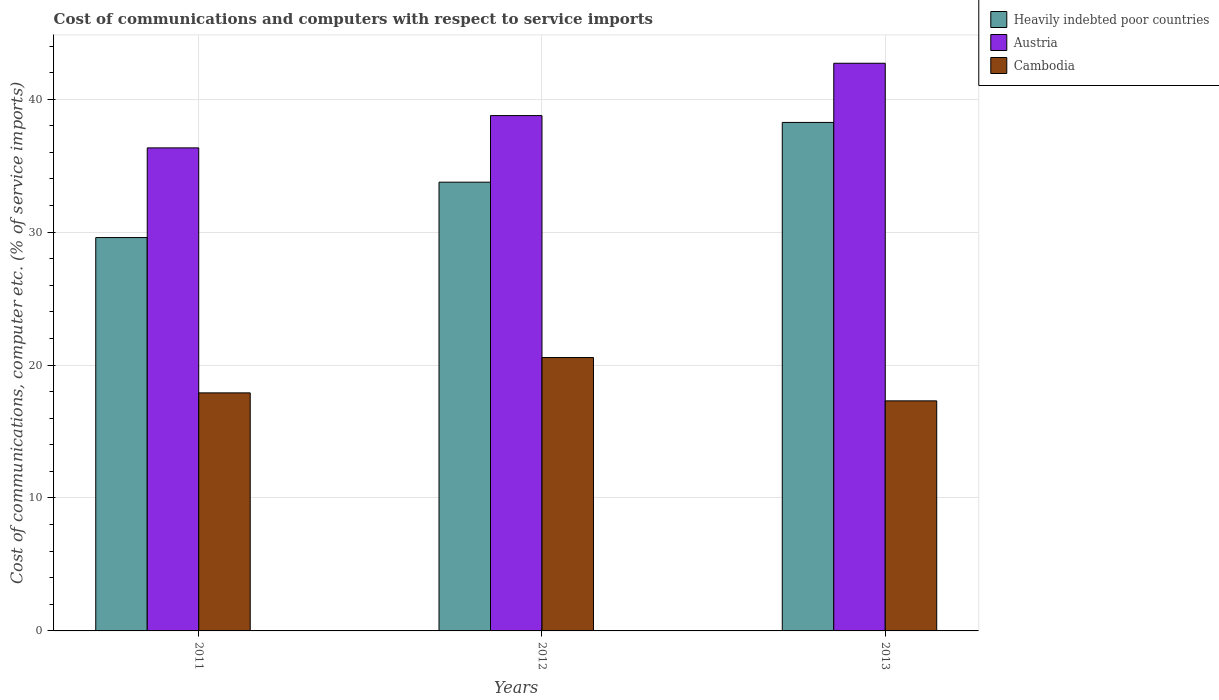Are the number of bars per tick equal to the number of legend labels?
Keep it short and to the point. Yes. Are the number of bars on each tick of the X-axis equal?
Keep it short and to the point. Yes. How many bars are there on the 1st tick from the left?
Your response must be concise. 3. In how many cases, is the number of bars for a given year not equal to the number of legend labels?
Keep it short and to the point. 0. What is the cost of communications and computers in Cambodia in 2012?
Make the answer very short. 20.57. Across all years, what is the maximum cost of communications and computers in Austria?
Make the answer very short. 42.7. Across all years, what is the minimum cost of communications and computers in Austria?
Provide a short and direct response. 36.34. In which year was the cost of communications and computers in Cambodia maximum?
Give a very brief answer. 2012. What is the total cost of communications and computers in Austria in the graph?
Your answer should be compact. 117.81. What is the difference between the cost of communications and computers in Austria in 2012 and that in 2013?
Your answer should be compact. -3.94. What is the difference between the cost of communications and computers in Austria in 2012 and the cost of communications and computers in Cambodia in 2013?
Provide a short and direct response. 21.46. What is the average cost of communications and computers in Cambodia per year?
Ensure brevity in your answer.  18.59. In the year 2011, what is the difference between the cost of communications and computers in Heavily indebted poor countries and cost of communications and computers in Austria?
Give a very brief answer. -6.75. What is the ratio of the cost of communications and computers in Cambodia in 2011 to that in 2013?
Provide a succinct answer. 1.03. Is the cost of communications and computers in Cambodia in 2011 less than that in 2013?
Keep it short and to the point. No. What is the difference between the highest and the second highest cost of communications and computers in Austria?
Offer a very short reply. 3.94. What is the difference between the highest and the lowest cost of communications and computers in Heavily indebted poor countries?
Ensure brevity in your answer.  8.66. Is the sum of the cost of communications and computers in Heavily indebted poor countries in 2012 and 2013 greater than the maximum cost of communications and computers in Cambodia across all years?
Offer a terse response. Yes. What does the 2nd bar from the left in 2012 represents?
Offer a terse response. Austria. How many bars are there?
Provide a short and direct response. 9. Are all the bars in the graph horizontal?
Keep it short and to the point. No. What is the difference between two consecutive major ticks on the Y-axis?
Your response must be concise. 10. Are the values on the major ticks of Y-axis written in scientific E-notation?
Your response must be concise. No. Does the graph contain any zero values?
Provide a short and direct response. No. How are the legend labels stacked?
Offer a terse response. Vertical. What is the title of the graph?
Your answer should be very brief. Cost of communications and computers with respect to service imports. What is the label or title of the Y-axis?
Your response must be concise. Cost of communications, computer etc. (% of service imports). What is the Cost of communications, computer etc. (% of service imports) of Heavily indebted poor countries in 2011?
Ensure brevity in your answer.  29.59. What is the Cost of communications, computer etc. (% of service imports) of Austria in 2011?
Ensure brevity in your answer.  36.34. What is the Cost of communications, computer etc. (% of service imports) of Cambodia in 2011?
Ensure brevity in your answer.  17.91. What is the Cost of communications, computer etc. (% of service imports) of Heavily indebted poor countries in 2012?
Give a very brief answer. 33.76. What is the Cost of communications, computer etc. (% of service imports) of Austria in 2012?
Provide a short and direct response. 38.77. What is the Cost of communications, computer etc. (% of service imports) of Cambodia in 2012?
Give a very brief answer. 20.57. What is the Cost of communications, computer etc. (% of service imports) of Heavily indebted poor countries in 2013?
Your answer should be very brief. 38.25. What is the Cost of communications, computer etc. (% of service imports) of Austria in 2013?
Offer a terse response. 42.7. What is the Cost of communications, computer etc. (% of service imports) in Cambodia in 2013?
Keep it short and to the point. 17.31. Across all years, what is the maximum Cost of communications, computer etc. (% of service imports) in Heavily indebted poor countries?
Provide a short and direct response. 38.25. Across all years, what is the maximum Cost of communications, computer etc. (% of service imports) of Austria?
Your answer should be very brief. 42.7. Across all years, what is the maximum Cost of communications, computer etc. (% of service imports) of Cambodia?
Your answer should be very brief. 20.57. Across all years, what is the minimum Cost of communications, computer etc. (% of service imports) of Heavily indebted poor countries?
Provide a succinct answer. 29.59. Across all years, what is the minimum Cost of communications, computer etc. (% of service imports) of Austria?
Provide a succinct answer. 36.34. Across all years, what is the minimum Cost of communications, computer etc. (% of service imports) in Cambodia?
Ensure brevity in your answer.  17.31. What is the total Cost of communications, computer etc. (% of service imports) in Heavily indebted poor countries in the graph?
Your response must be concise. 101.6. What is the total Cost of communications, computer etc. (% of service imports) in Austria in the graph?
Provide a succinct answer. 117.81. What is the total Cost of communications, computer etc. (% of service imports) in Cambodia in the graph?
Offer a terse response. 55.78. What is the difference between the Cost of communications, computer etc. (% of service imports) in Heavily indebted poor countries in 2011 and that in 2012?
Provide a succinct answer. -4.17. What is the difference between the Cost of communications, computer etc. (% of service imports) of Austria in 2011 and that in 2012?
Ensure brevity in your answer.  -2.43. What is the difference between the Cost of communications, computer etc. (% of service imports) of Cambodia in 2011 and that in 2012?
Make the answer very short. -2.66. What is the difference between the Cost of communications, computer etc. (% of service imports) in Heavily indebted poor countries in 2011 and that in 2013?
Your answer should be very brief. -8.66. What is the difference between the Cost of communications, computer etc. (% of service imports) of Austria in 2011 and that in 2013?
Ensure brevity in your answer.  -6.37. What is the difference between the Cost of communications, computer etc. (% of service imports) in Cambodia in 2011 and that in 2013?
Give a very brief answer. 0.6. What is the difference between the Cost of communications, computer etc. (% of service imports) in Heavily indebted poor countries in 2012 and that in 2013?
Offer a terse response. -4.5. What is the difference between the Cost of communications, computer etc. (% of service imports) in Austria in 2012 and that in 2013?
Your answer should be very brief. -3.94. What is the difference between the Cost of communications, computer etc. (% of service imports) in Cambodia in 2012 and that in 2013?
Keep it short and to the point. 3.26. What is the difference between the Cost of communications, computer etc. (% of service imports) of Heavily indebted poor countries in 2011 and the Cost of communications, computer etc. (% of service imports) of Austria in 2012?
Keep it short and to the point. -9.18. What is the difference between the Cost of communications, computer etc. (% of service imports) in Heavily indebted poor countries in 2011 and the Cost of communications, computer etc. (% of service imports) in Cambodia in 2012?
Your answer should be compact. 9.03. What is the difference between the Cost of communications, computer etc. (% of service imports) in Austria in 2011 and the Cost of communications, computer etc. (% of service imports) in Cambodia in 2012?
Your answer should be very brief. 15.77. What is the difference between the Cost of communications, computer etc. (% of service imports) of Heavily indebted poor countries in 2011 and the Cost of communications, computer etc. (% of service imports) of Austria in 2013?
Make the answer very short. -13.11. What is the difference between the Cost of communications, computer etc. (% of service imports) of Heavily indebted poor countries in 2011 and the Cost of communications, computer etc. (% of service imports) of Cambodia in 2013?
Give a very brief answer. 12.28. What is the difference between the Cost of communications, computer etc. (% of service imports) of Austria in 2011 and the Cost of communications, computer etc. (% of service imports) of Cambodia in 2013?
Make the answer very short. 19.03. What is the difference between the Cost of communications, computer etc. (% of service imports) of Heavily indebted poor countries in 2012 and the Cost of communications, computer etc. (% of service imports) of Austria in 2013?
Offer a very short reply. -8.95. What is the difference between the Cost of communications, computer etc. (% of service imports) of Heavily indebted poor countries in 2012 and the Cost of communications, computer etc. (% of service imports) of Cambodia in 2013?
Give a very brief answer. 16.45. What is the difference between the Cost of communications, computer etc. (% of service imports) in Austria in 2012 and the Cost of communications, computer etc. (% of service imports) in Cambodia in 2013?
Your response must be concise. 21.46. What is the average Cost of communications, computer etc. (% of service imports) of Heavily indebted poor countries per year?
Your response must be concise. 33.87. What is the average Cost of communications, computer etc. (% of service imports) of Austria per year?
Offer a very short reply. 39.27. What is the average Cost of communications, computer etc. (% of service imports) of Cambodia per year?
Provide a succinct answer. 18.59. In the year 2011, what is the difference between the Cost of communications, computer etc. (% of service imports) of Heavily indebted poor countries and Cost of communications, computer etc. (% of service imports) of Austria?
Offer a terse response. -6.75. In the year 2011, what is the difference between the Cost of communications, computer etc. (% of service imports) of Heavily indebted poor countries and Cost of communications, computer etc. (% of service imports) of Cambodia?
Ensure brevity in your answer.  11.68. In the year 2011, what is the difference between the Cost of communications, computer etc. (% of service imports) in Austria and Cost of communications, computer etc. (% of service imports) in Cambodia?
Offer a terse response. 18.43. In the year 2012, what is the difference between the Cost of communications, computer etc. (% of service imports) of Heavily indebted poor countries and Cost of communications, computer etc. (% of service imports) of Austria?
Provide a succinct answer. -5.01. In the year 2012, what is the difference between the Cost of communications, computer etc. (% of service imports) of Heavily indebted poor countries and Cost of communications, computer etc. (% of service imports) of Cambodia?
Give a very brief answer. 13.19. In the year 2012, what is the difference between the Cost of communications, computer etc. (% of service imports) in Austria and Cost of communications, computer etc. (% of service imports) in Cambodia?
Give a very brief answer. 18.2. In the year 2013, what is the difference between the Cost of communications, computer etc. (% of service imports) in Heavily indebted poor countries and Cost of communications, computer etc. (% of service imports) in Austria?
Make the answer very short. -4.45. In the year 2013, what is the difference between the Cost of communications, computer etc. (% of service imports) of Heavily indebted poor countries and Cost of communications, computer etc. (% of service imports) of Cambodia?
Ensure brevity in your answer.  20.95. In the year 2013, what is the difference between the Cost of communications, computer etc. (% of service imports) of Austria and Cost of communications, computer etc. (% of service imports) of Cambodia?
Offer a very short reply. 25.4. What is the ratio of the Cost of communications, computer etc. (% of service imports) of Heavily indebted poor countries in 2011 to that in 2012?
Offer a very short reply. 0.88. What is the ratio of the Cost of communications, computer etc. (% of service imports) in Austria in 2011 to that in 2012?
Your answer should be very brief. 0.94. What is the ratio of the Cost of communications, computer etc. (% of service imports) of Cambodia in 2011 to that in 2012?
Ensure brevity in your answer.  0.87. What is the ratio of the Cost of communications, computer etc. (% of service imports) in Heavily indebted poor countries in 2011 to that in 2013?
Your answer should be compact. 0.77. What is the ratio of the Cost of communications, computer etc. (% of service imports) of Austria in 2011 to that in 2013?
Your answer should be very brief. 0.85. What is the ratio of the Cost of communications, computer etc. (% of service imports) in Cambodia in 2011 to that in 2013?
Keep it short and to the point. 1.03. What is the ratio of the Cost of communications, computer etc. (% of service imports) of Heavily indebted poor countries in 2012 to that in 2013?
Offer a terse response. 0.88. What is the ratio of the Cost of communications, computer etc. (% of service imports) of Austria in 2012 to that in 2013?
Give a very brief answer. 0.91. What is the ratio of the Cost of communications, computer etc. (% of service imports) of Cambodia in 2012 to that in 2013?
Offer a terse response. 1.19. What is the difference between the highest and the second highest Cost of communications, computer etc. (% of service imports) in Heavily indebted poor countries?
Your answer should be very brief. 4.5. What is the difference between the highest and the second highest Cost of communications, computer etc. (% of service imports) in Austria?
Provide a short and direct response. 3.94. What is the difference between the highest and the second highest Cost of communications, computer etc. (% of service imports) in Cambodia?
Provide a short and direct response. 2.66. What is the difference between the highest and the lowest Cost of communications, computer etc. (% of service imports) of Heavily indebted poor countries?
Provide a succinct answer. 8.66. What is the difference between the highest and the lowest Cost of communications, computer etc. (% of service imports) of Austria?
Offer a very short reply. 6.37. What is the difference between the highest and the lowest Cost of communications, computer etc. (% of service imports) in Cambodia?
Offer a terse response. 3.26. 